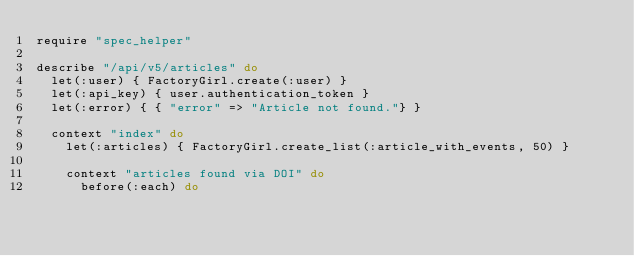<code> <loc_0><loc_0><loc_500><loc_500><_Ruby_>require "spec_helper"

describe "/api/v5/articles" do
  let(:user) { FactoryGirl.create(:user) }
  let(:api_key) { user.authentication_token }
  let(:error) { { "error" => "Article not found."} }

  context "index" do
    let(:articles) { FactoryGirl.create_list(:article_with_events, 50) }

    context "articles found via DOI" do
      before(:each) do</code> 